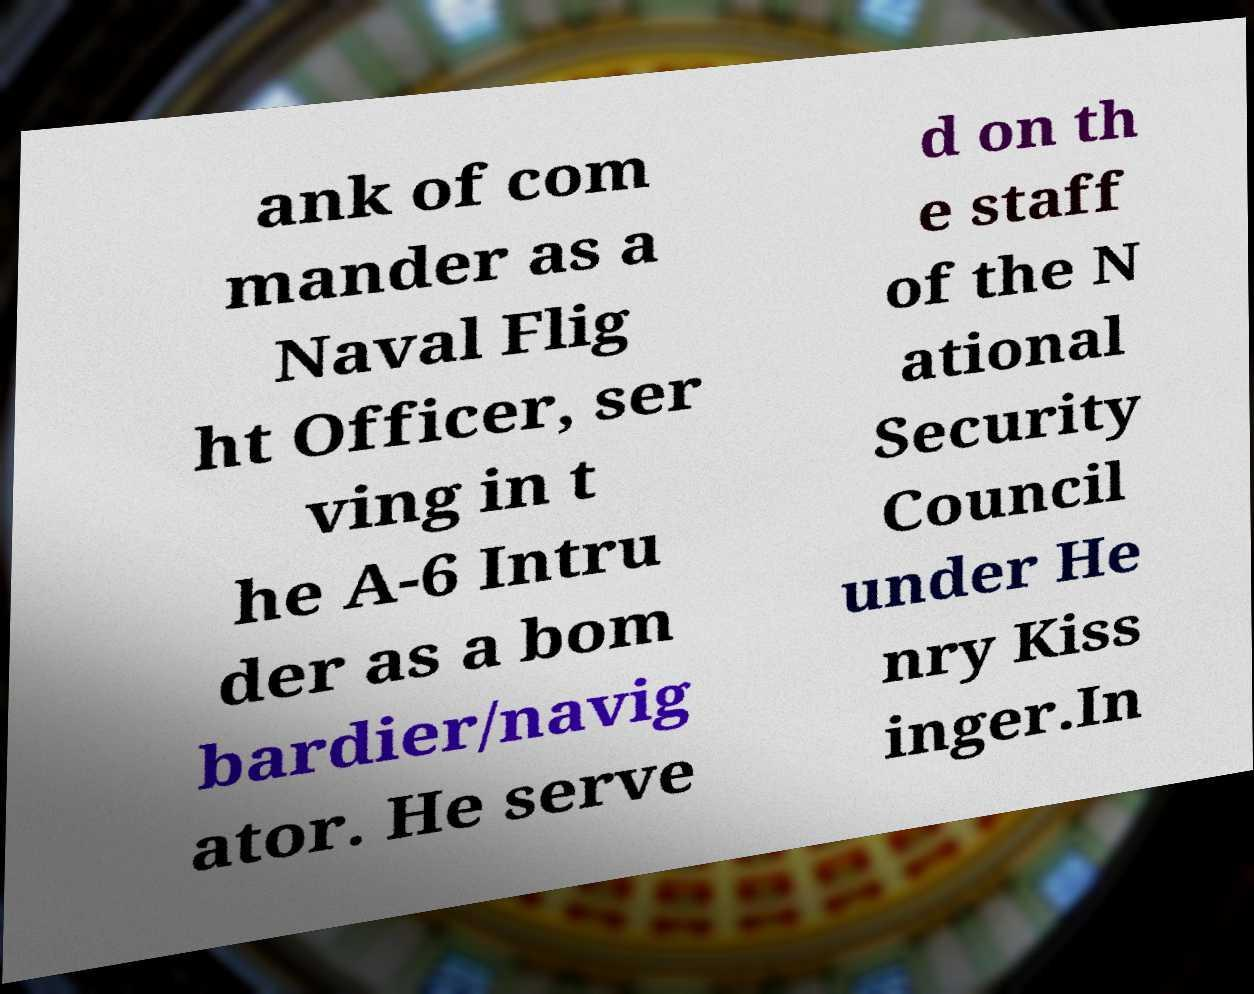Can you accurately transcribe the text from the provided image for me? ank of com mander as a Naval Flig ht Officer, ser ving in t he A-6 Intru der as a bom bardier/navig ator. He serve d on th e staff of the N ational Security Council under He nry Kiss inger.In 